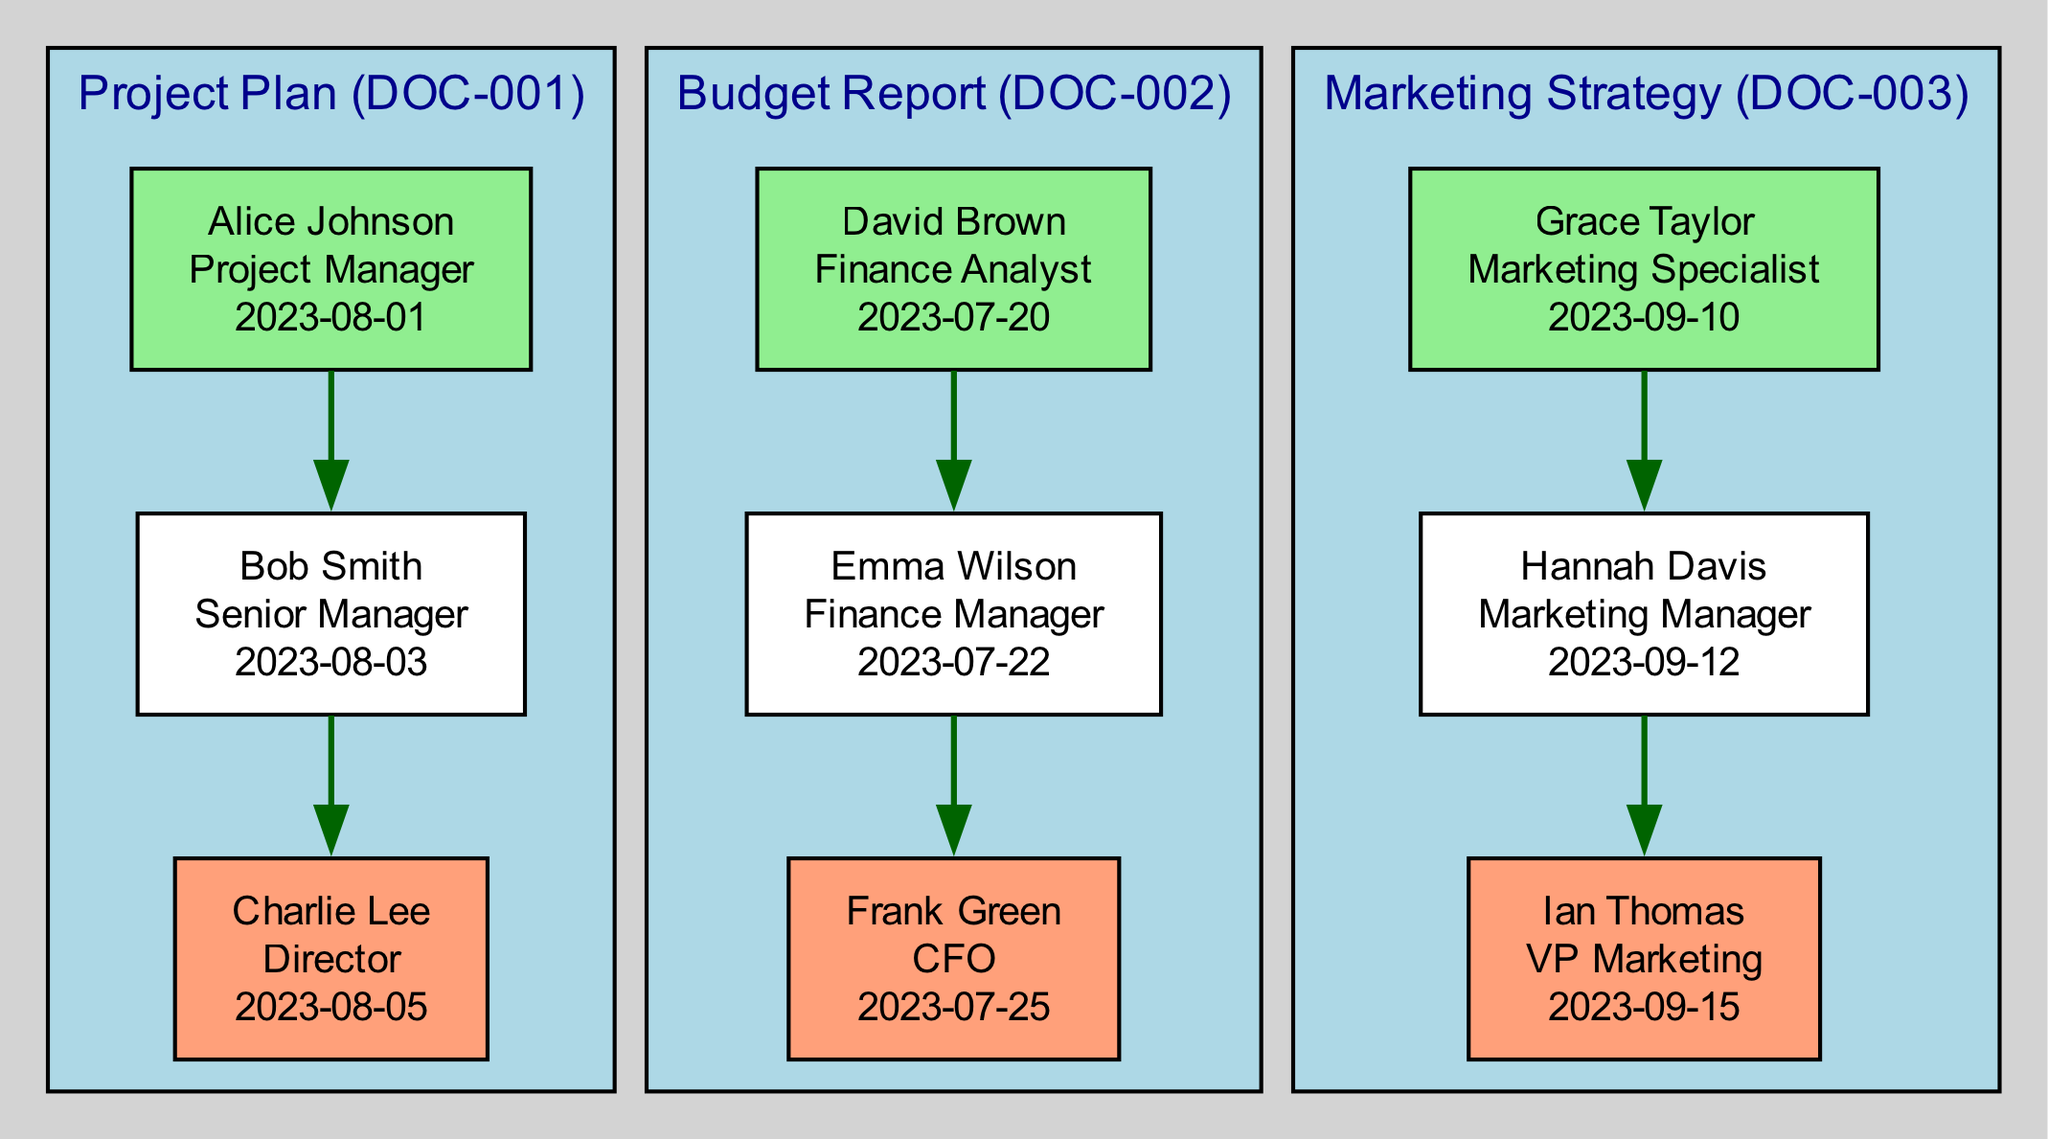What is the name of the last approver for the Project Plan? In the approval chain for the Project Plan, the last approver listed is Charlie Lee.
Answer: Charlie Lee How many documents are displayed in the diagram? There are three documents listed in the diagram: Project Plan, Budget Report, and Marketing Strategy.
Answer: Three Who approved the Budget Report on July 22, 2023? In the approval chain for the Budget Report, the approver on July 22, 2023, is Emma Wilson.
Answer: Emma Wilson What role does Grace Taylor hold? In the approval chain for the Marketing Strategy, Grace Taylor is identified as a Marketing Specialist.
Answer: Marketing Specialist Which document was approved first, the Budget Report or the Project Plan? The Budget Report was approved first on July 20, 2023, while the Project Plan was approved starting on August 1, 2023.
Answer: Budget Report Who is the first approver listed for the Marketing Strategy? The first approver in the Marketing Strategy approval chain is Grace Taylor.
Answer: Grace Taylor How many total approvers are involved in approving the Project Plan? The Project Plan has three approvers: Alice Johnson, Bob Smith, and Charlie Lee.
Answer: Three What is the approval date for the CFO's sign-off on the Budget Report? The CFO, Frank Green, approved the Budget Report on July 25, 2023.
Answer: July 25, 2023 Which document has the approval from a VP? The Marketing Strategy is the only document that has approval from a VP, which is Ian Thomas.
Answer: Marketing Strategy 